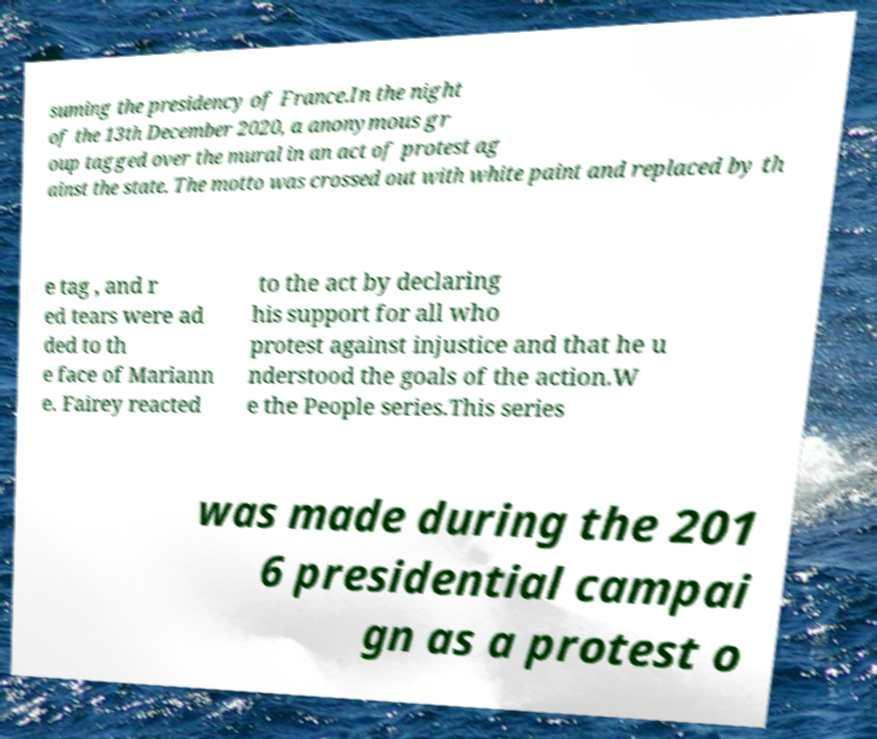Could you extract and type out the text from this image? suming the presidency of France.In the night of the 13th December 2020, a anonymous gr oup tagged over the mural in an act of protest ag ainst the state. The motto was crossed out with white paint and replaced by th e tag , and r ed tears were ad ded to th e face of Mariann e. Fairey reacted to the act by declaring his support for all who protest against injustice and that he u nderstood the goals of the action.W e the People series.This series was made during the 201 6 presidential campai gn as a protest o 